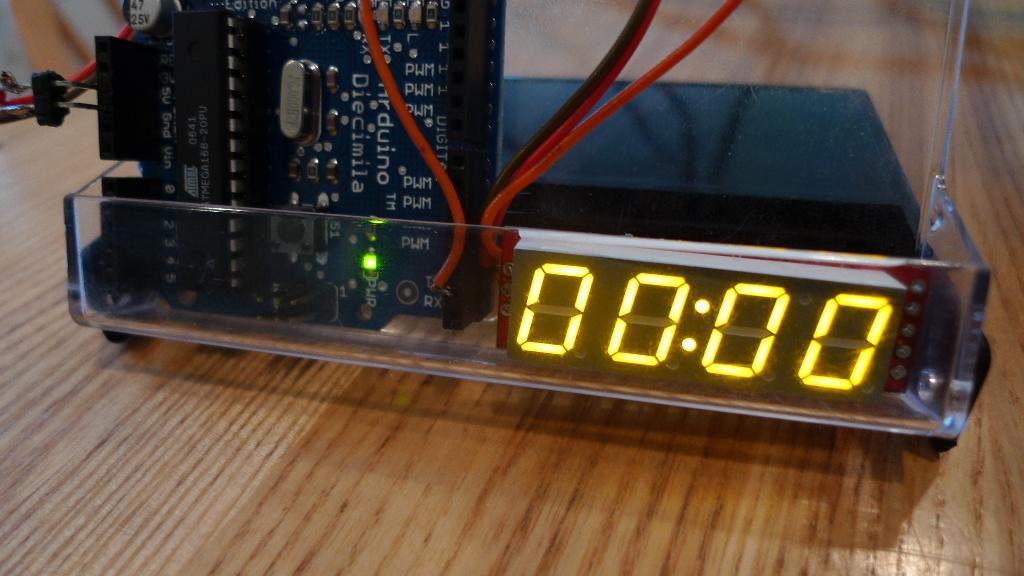What is the seven segment display showing?
Give a very brief answer. 00:00. What are the 4 numbers being displayed?
Ensure brevity in your answer.  0000. 